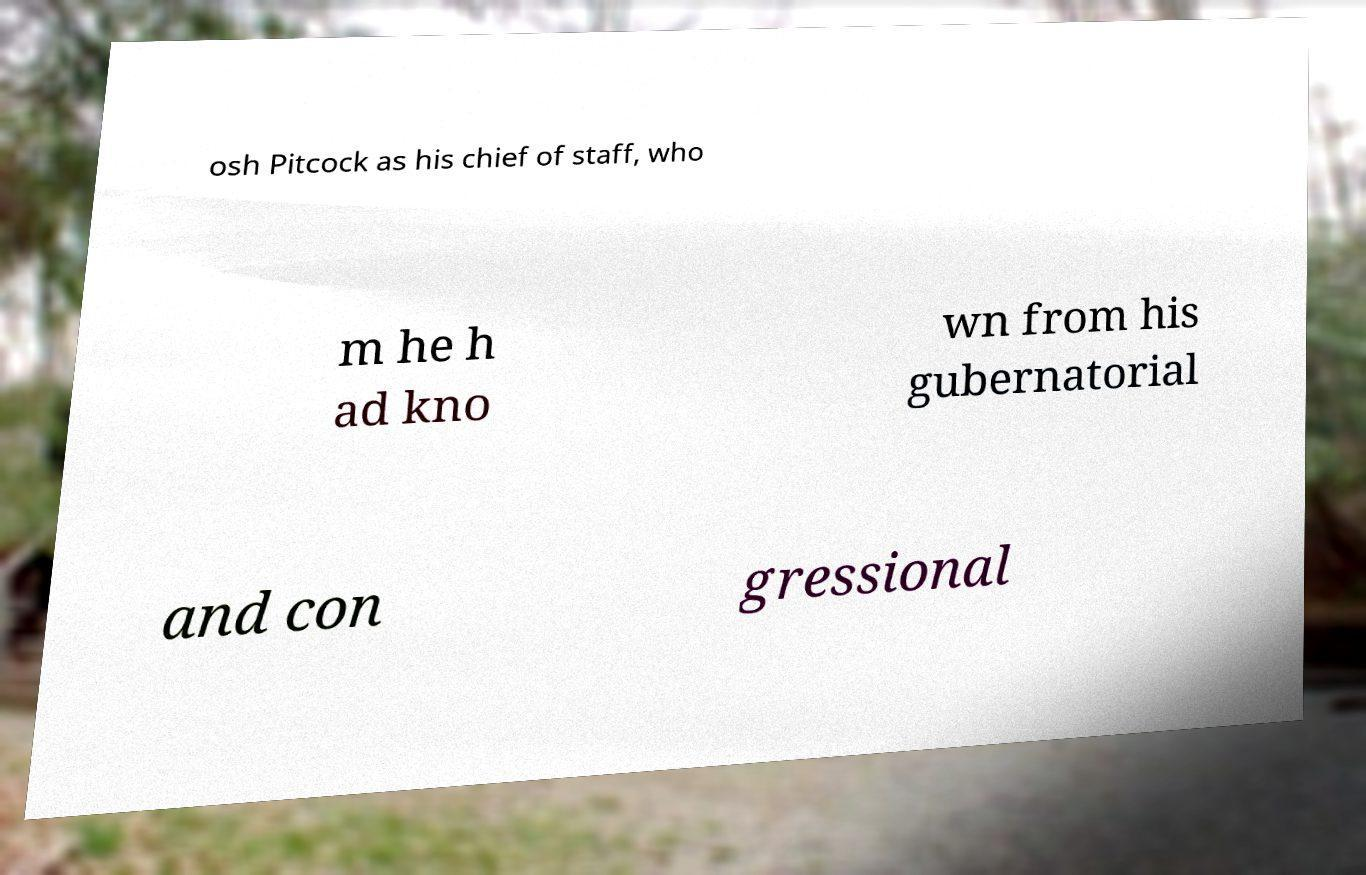For documentation purposes, I need the text within this image transcribed. Could you provide that? osh Pitcock as his chief of staff, who m he h ad kno wn from his gubernatorial and con gressional 